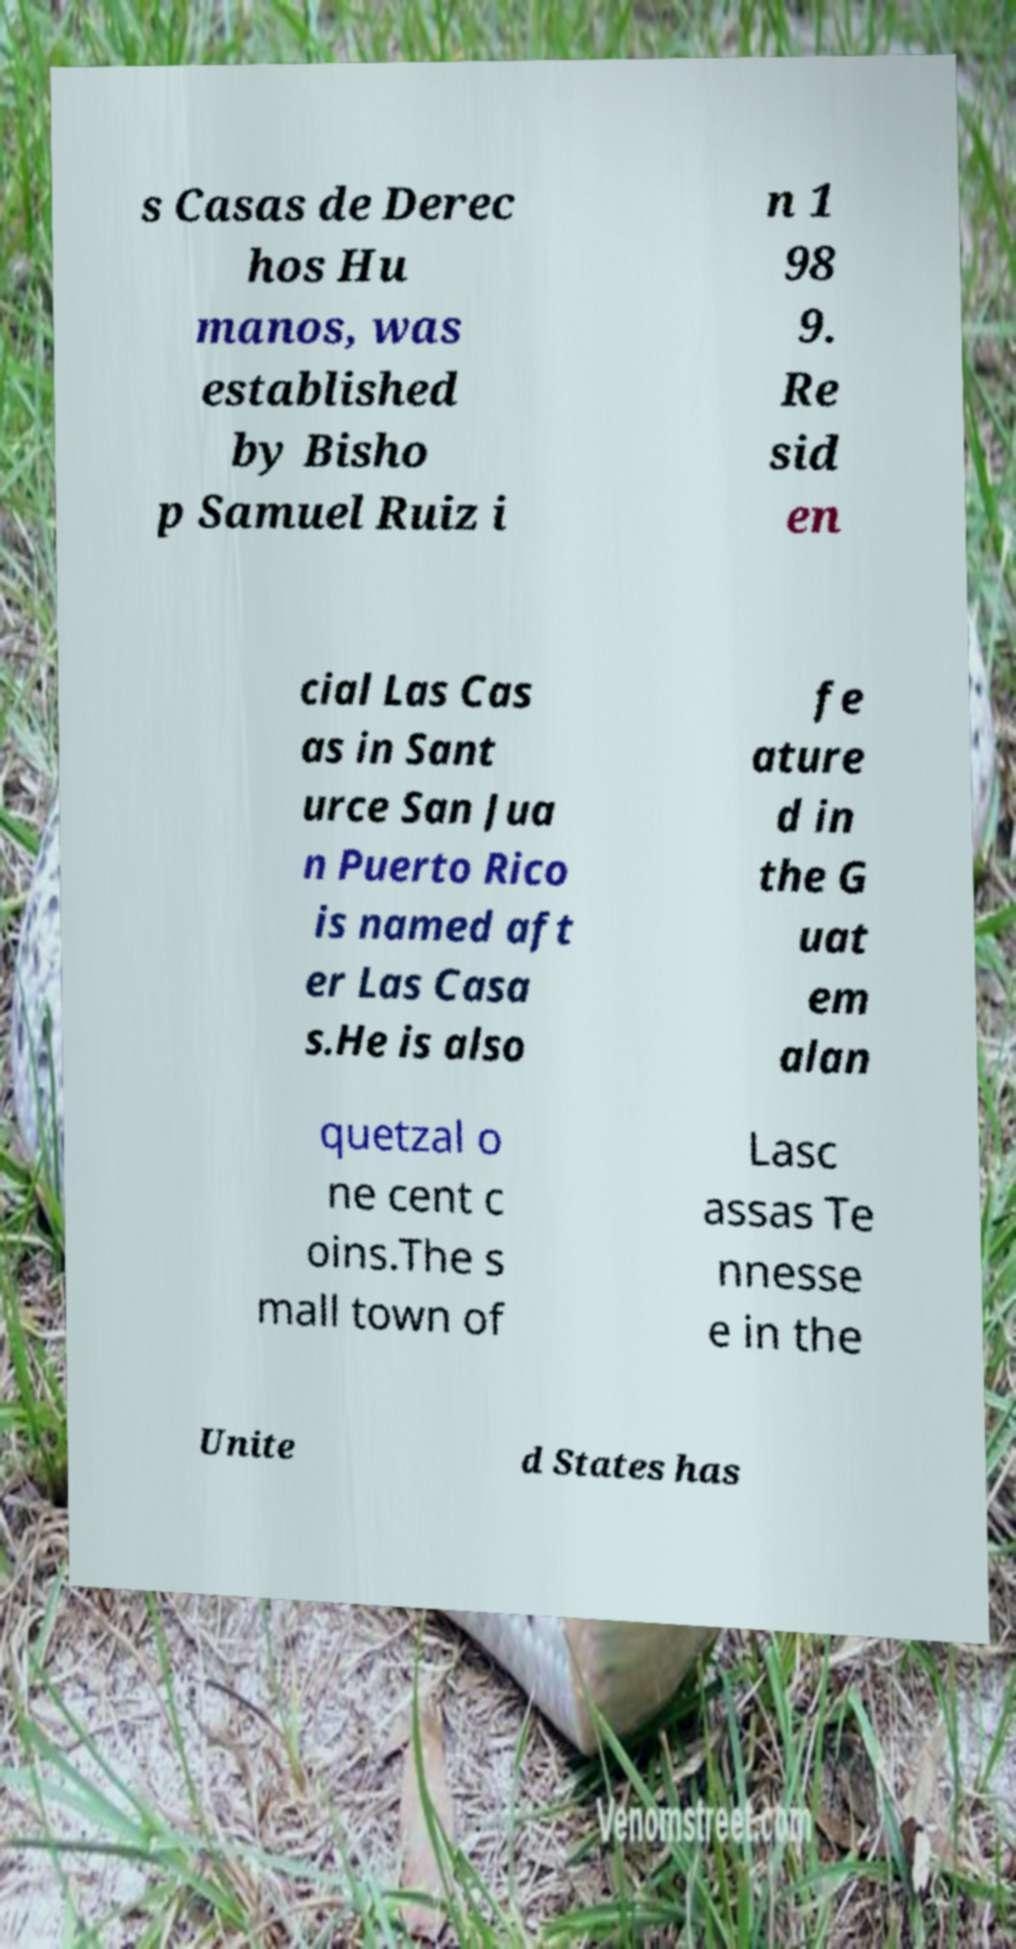Please identify and transcribe the text found in this image. s Casas de Derec hos Hu manos, was established by Bisho p Samuel Ruiz i n 1 98 9. Re sid en cial Las Cas as in Sant urce San Jua n Puerto Rico is named aft er Las Casa s.He is also fe ature d in the G uat em alan quetzal o ne cent c oins.The s mall town of Lasc assas Te nnesse e in the Unite d States has 